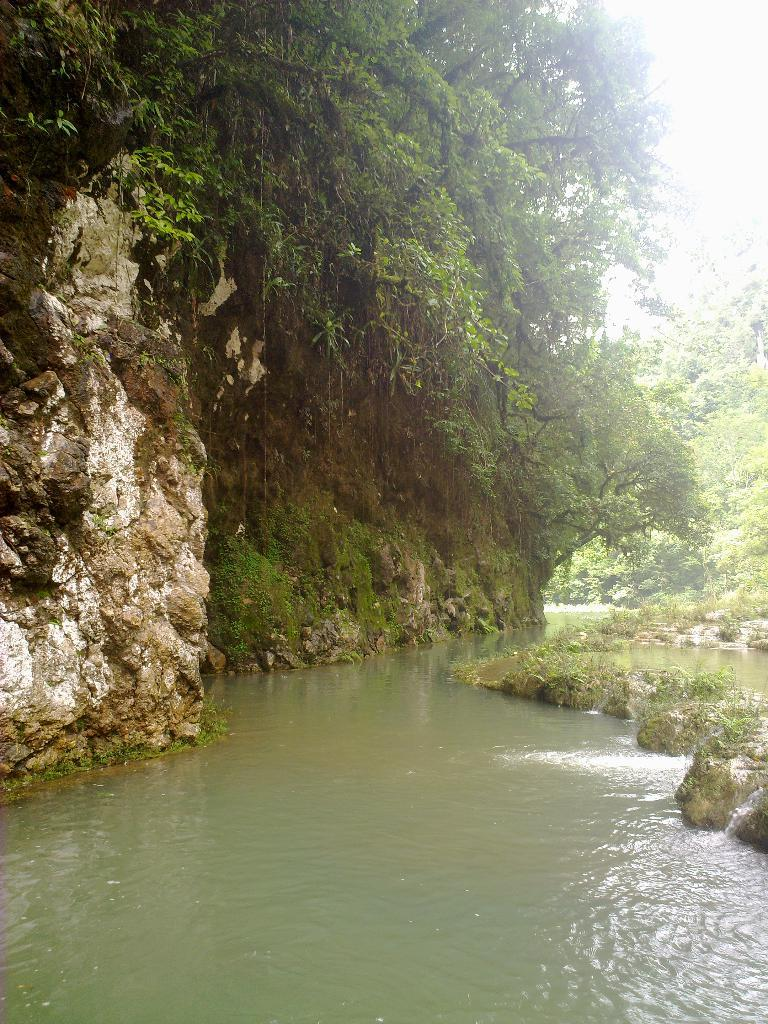What is the main subject of the image? The main subject of the image is a rock. What other natural elements can be seen in the image? There are trees and a lake visible in the image. What type of salt can be seen on the rock in the image? There is no salt present on the rock in the image. What type of camera was used to take the picture of the rock? The type of camera used to take the picture is not mentioned in the image or the provided facts. 